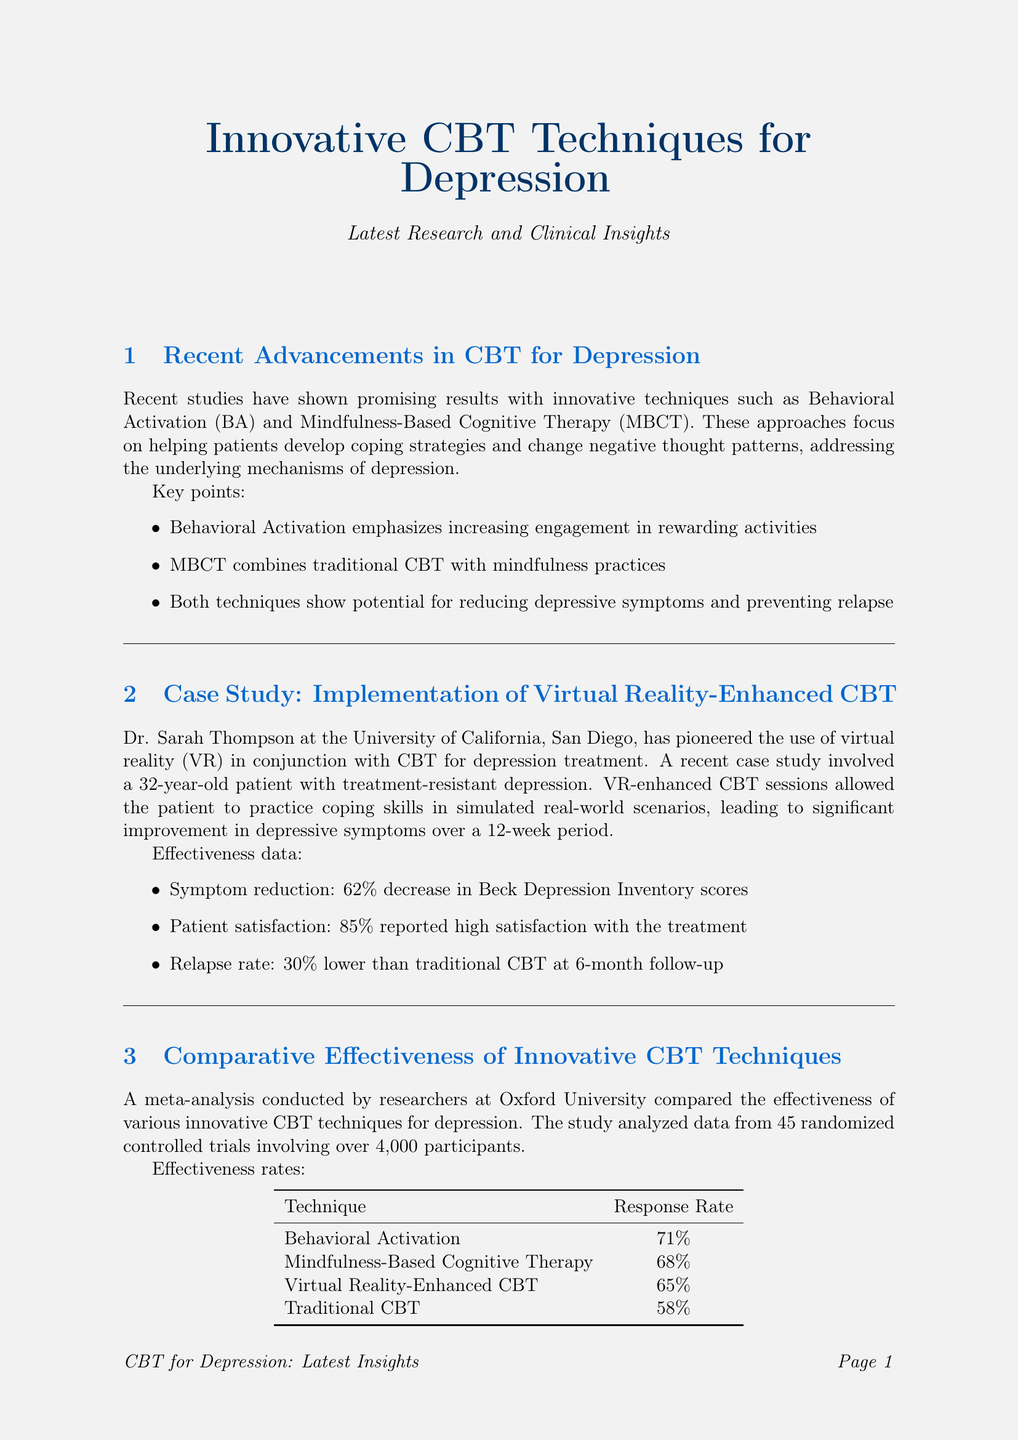What are the two innovative techniques mentioned for treating depression? The document highlights Behavioral Activation and Mindfulness-Based Cognitive Therapy as innovative techniques for treating depression.
Answer: Behavioral Activation, Mindfulness-Based Cognitive Therapy Who conducted the meta-analysis on innovative CBT techniques? The meta-analysis was conducted by researchers at Oxford University.
Answer: Oxford University What was the symptom reduction percentage in the case study using VR-enhanced CBT? The symptom reduction percentage was a 62% decrease in Beck Depression Inventory scores reported in the case study.
Answer: 62% What is the response rate of Behavioral Activation according to the meta-analysis? The meta-analysis indicates a response rate of 71% for Behavioral Activation.
Answer: 71% What is the funding amount for innovative depression treatments from the National Institute of Mental Health? The National Institute of Mental Health offers a grant of $5 million for innovative depression treatments.
Answer: $5 million How much lower was the relapse rate compared to traditional CBT in the VR-enhanced CBT case study? The relapse rate was reported to be 30% lower than traditional CBT at the 6-month follow-up in the case study.
Answer: 30% What brain area showed increased activity with Behavioral Activation? The research revealed that Behavioral Activation was associated with increased activity in the reward centers of the brain.
Answer: reward centers What are two emerging areas in CBT for depression research mentioned in the document? The document lists the integration of digital health technologies and investigation of cultural adaptations as emerging areas in CBT for depression research.
Answer: digital health technologies, cultural adaptations 